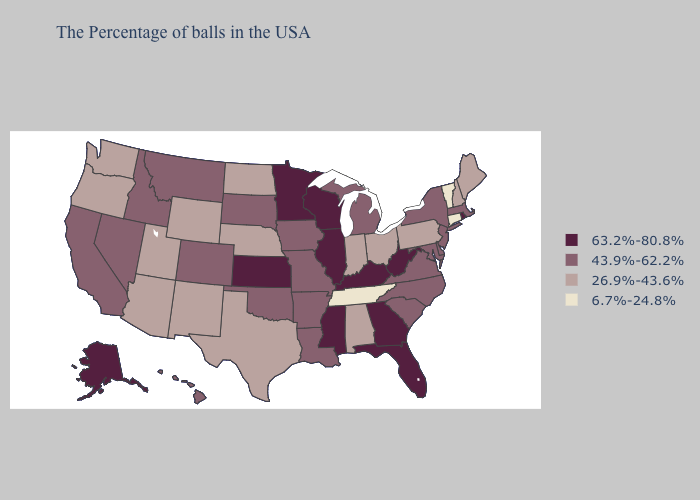Does Maryland have a higher value than Kansas?
Write a very short answer. No. Does Nevada have the highest value in the USA?
Answer briefly. No. Does the first symbol in the legend represent the smallest category?
Write a very short answer. No. Does Vermont have a lower value than Connecticut?
Give a very brief answer. No. Name the states that have a value in the range 6.7%-24.8%?
Concise answer only. Vermont, Connecticut, Tennessee. Which states have the lowest value in the West?
Give a very brief answer. Wyoming, New Mexico, Utah, Arizona, Washington, Oregon. Does New Mexico have the same value as South Carolina?
Be succinct. No. Name the states that have a value in the range 26.9%-43.6%?
Concise answer only. Maine, New Hampshire, Pennsylvania, Ohio, Indiana, Alabama, Nebraska, Texas, North Dakota, Wyoming, New Mexico, Utah, Arizona, Washington, Oregon. What is the value of California?
Answer briefly. 43.9%-62.2%. What is the highest value in states that border Minnesota?
Write a very short answer. 63.2%-80.8%. What is the value of Delaware?
Write a very short answer. 43.9%-62.2%. Does New York have the highest value in the USA?
Answer briefly. No. What is the value of Tennessee?
Keep it brief. 6.7%-24.8%. What is the value of Wyoming?
Keep it brief. 26.9%-43.6%. Does Rhode Island have the lowest value in the Northeast?
Give a very brief answer. No. 